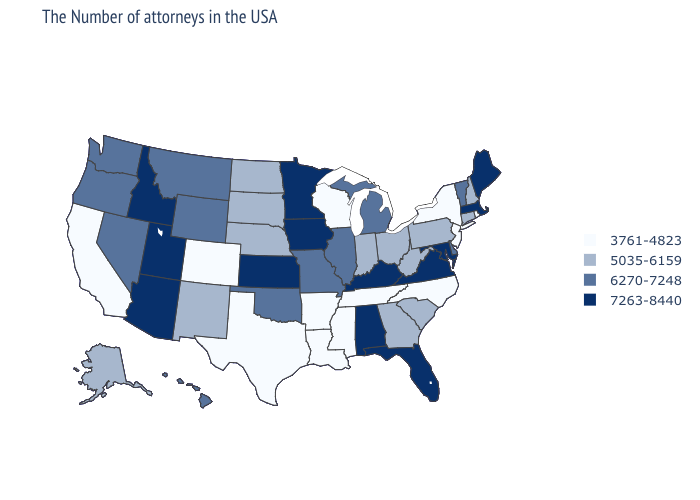Which states hav the highest value in the Northeast?
Quick response, please. Maine, Massachusetts. Which states have the lowest value in the USA?
Short answer required. Rhode Island, New York, New Jersey, North Carolina, Tennessee, Wisconsin, Mississippi, Louisiana, Arkansas, Texas, Colorado, California. Does Vermont have the highest value in the USA?
Concise answer only. No. Name the states that have a value in the range 5035-6159?
Give a very brief answer. New Hampshire, Connecticut, Pennsylvania, South Carolina, West Virginia, Ohio, Georgia, Indiana, Nebraska, South Dakota, North Dakota, New Mexico, Alaska. What is the lowest value in the USA?
Quick response, please. 3761-4823. Does Nebraska have the lowest value in the MidWest?
Answer briefly. No. What is the highest value in the Northeast ?
Write a very short answer. 7263-8440. Name the states that have a value in the range 3761-4823?
Write a very short answer. Rhode Island, New York, New Jersey, North Carolina, Tennessee, Wisconsin, Mississippi, Louisiana, Arkansas, Texas, Colorado, California. Name the states that have a value in the range 3761-4823?
Give a very brief answer. Rhode Island, New York, New Jersey, North Carolina, Tennessee, Wisconsin, Mississippi, Louisiana, Arkansas, Texas, Colorado, California. Name the states that have a value in the range 3761-4823?
Give a very brief answer. Rhode Island, New York, New Jersey, North Carolina, Tennessee, Wisconsin, Mississippi, Louisiana, Arkansas, Texas, Colorado, California. Does the map have missing data?
Be succinct. No. Which states have the highest value in the USA?
Concise answer only. Maine, Massachusetts, Maryland, Virginia, Florida, Kentucky, Alabama, Minnesota, Iowa, Kansas, Utah, Arizona, Idaho. What is the value of Massachusetts?
Write a very short answer. 7263-8440. Name the states that have a value in the range 6270-7248?
Answer briefly. Vermont, Delaware, Michigan, Illinois, Missouri, Oklahoma, Wyoming, Montana, Nevada, Washington, Oregon, Hawaii. Does Massachusetts have the highest value in the Northeast?
Quick response, please. Yes. 